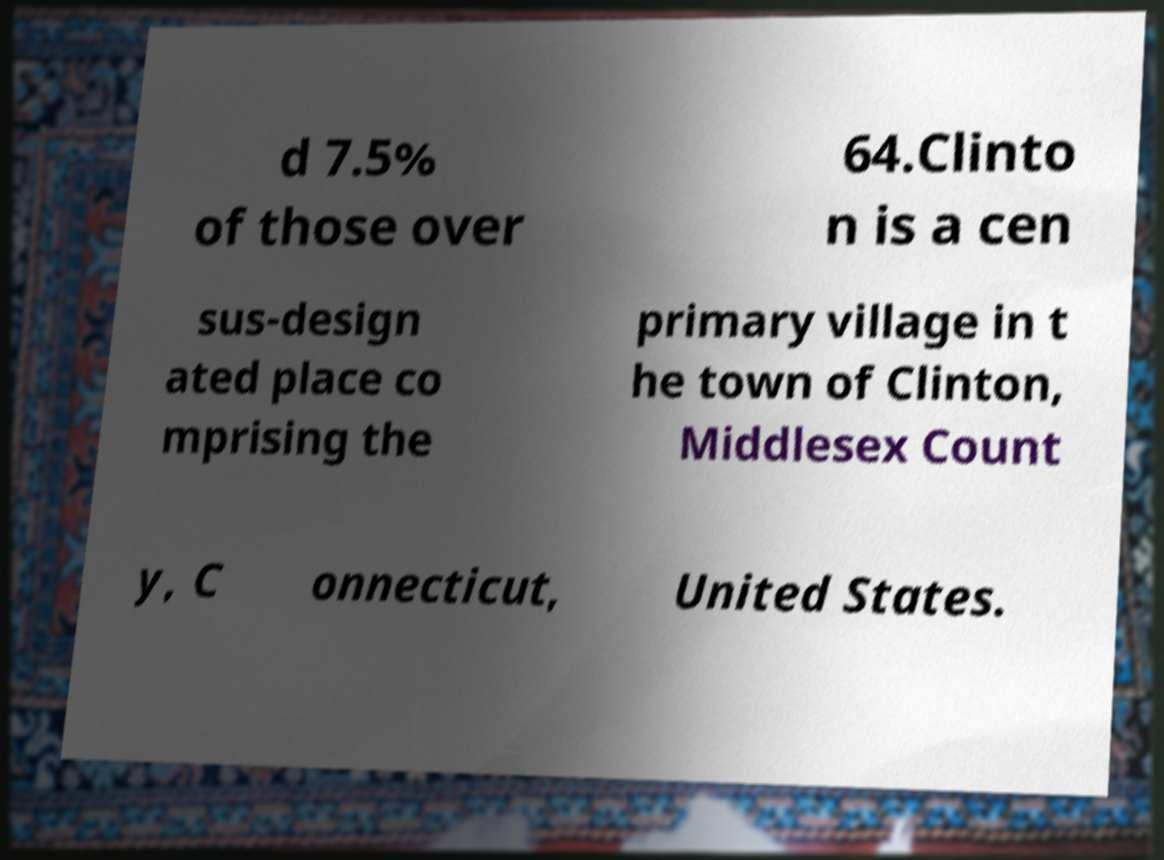Please identify and transcribe the text found in this image. d 7.5% of those over 64.Clinto n is a cen sus-design ated place co mprising the primary village in t he town of Clinton, Middlesex Count y, C onnecticut, United States. 